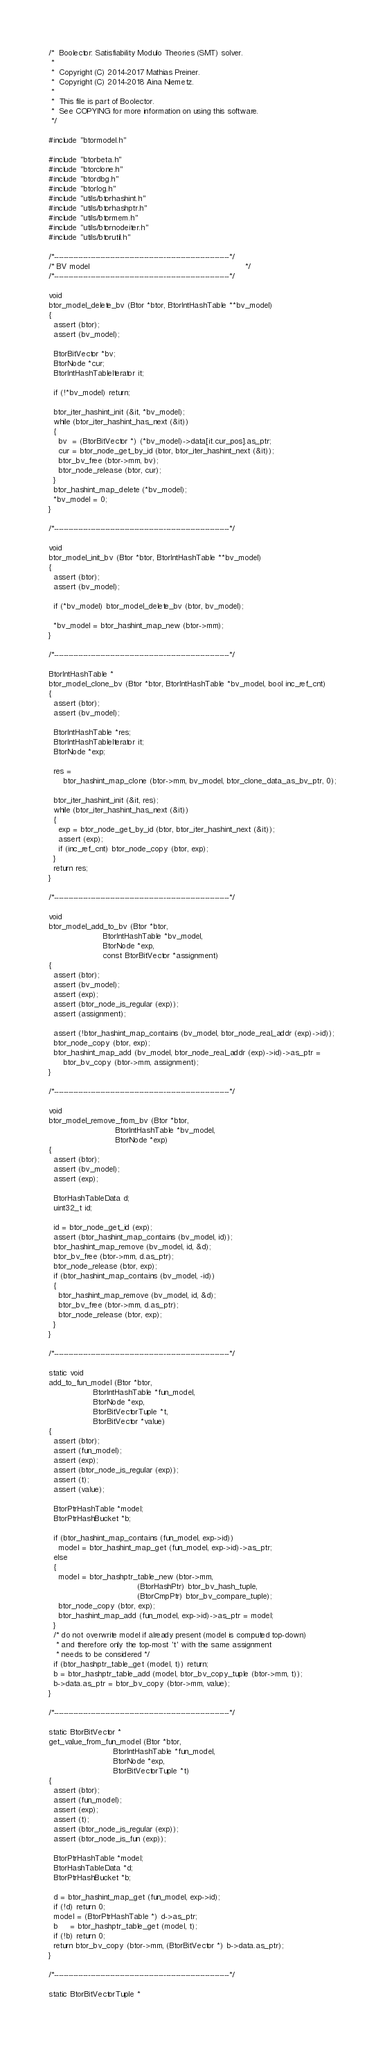Convert code to text. <code><loc_0><loc_0><loc_500><loc_500><_C_>/*  Boolector: Satisfiability Modulo Theories (SMT) solver.
 *
 *  Copyright (C) 2014-2017 Mathias Preiner.
 *  Copyright (C) 2014-2018 Aina Niemetz.
 *
 *  This file is part of Boolector.
 *  See COPYING for more information on using this software.
 */

#include "btormodel.h"

#include "btorbeta.h"
#include "btorclone.h"
#include "btordbg.h"
#include "btorlog.h"
#include "utils/btorhashint.h"
#include "utils/btorhashptr.h"
#include "utils/btormem.h"
#include "utils/btornodeiter.h"
#include "utils/btorutil.h"

/*------------------------------------------------------------------------*/
/* BV model                                                               */
/*------------------------------------------------------------------------*/

void
btor_model_delete_bv (Btor *btor, BtorIntHashTable **bv_model)
{
  assert (btor);
  assert (bv_model);

  BtorBitVector *bv;
  BtorNode *cur;
  BtorIntHashTableIterator it;

  if (!*bv_model) return;

  btor_iter_hashint_init (&it, *bv_model);
  while (btor_iter_hashint_has_next (&it))
  {
    bv  = (BtorBitVector *) (*bv_model)->data[it.cur_pos].as_ptr;
    cur = btor_node_get_by_id (btor, btor_iter_hashint_next (&it));
    btor_bv_free (btor->mm, bv);
    btor_node_release (btor, cur);
  }
  btor_hashint_map_delete (*bv_model);
  *bv_model = 0;
}

/*------------------------------------------------------------------------*/

void
btor_model_init_bv (Btor *btor, BtorIntHashTable **bv_model)
{
  assert (btor);
  assert (bv_model);

  if (*bv_model) btor_model_delete_bv (btor, bv_model);

  *bv_model = btor_hashint_map_new (btor->mm);
}

/*------------------------------------------------------------------------*/

BtorIntHashTable *
btor_model_clone_bv (Btor *btor, BtorIntHashTable *bv_model, bool inc_ref_cnt)
{
  assert (btor);
  assert (bv_model);

  BtorIntHashTable *res;
  BtorIntHashTableIterator it;
  BtorNode *exp;

  res =
      btor_hashint_map_clone (btor->mm, bv_model, btor_clone_data_as_bv_ptr, 0);

  btor_iter_hashint_init (&it, res);
  while (btor_iter_hashint_has_next (&it))
  {
    exp = btor_node_get_by_id (btor, btor_iter_hashint_next (&it));
    assert (exp);
    if (inc_ref_cnt) btor_node_copy (btor, exp);
  }
  return res;
}

/*------------------------------------------------------------------------*/

void
btor_model_add_to_bv (Btor *btor,
                      BtorIntHashTable *bv_model,
                      BtorNode *exp,
                      const BtorBitVector *assignment)
{
  assert (btor);
  assert (bv_model);
  assert (exp);
  assert (btor_node_is_regular (exp));
  assert (assignment);

  assert (!btor_hashint_map_contains (bv_model, btor_node_real_addr (exp)->id));
  btor_node_copy (btor, exp);
  btor_hashint_map_add (bv_model, btor_node_real_addr (exp)->id)->as_ptr =
      btor_bv_copy (btor->mm, assignment);
}

/*------------------------------------------------------------------------*/

void
btor_model_remove_from_bv (Btor *btor,
                           BtorIntHashTable *bv_model,
                           BtorNode *exp)
{
  assert (btor);
  assert (bv_model);
  assert (exp);

  BtorHashTableData d;
  uint32_t id;

  id = btor_node_get_id (exp);
  assert (btor_hashint_map_contains (bv_model, id));
  btor_hashint_map_remove (bv_model, id, &d);
  btor_bv_free (btor->mm, d.as_ptr);
  btor_node_release (btor, exp);
  if (btor_hashint_map_contains (bv_model, -id))
  {
    btor_hashint_map_remove (bv_model, id, &d);
    btor_bv_free (btor->mm, d.as_ptr);
    btor_node_release (btor, exp);
  }
}

/*------------------------------------------------------------------------*/

static void
add_to_fun_model (Btor *btor,
                  BtorIntHashTable *fun_model,
                  BtorNode *exp,
                  BtorBitVectorTuple *t,
                  BtorBitVector *value)
{
  assert (btor);
  assert (fun_model);
  assert (exp);
  assert (btor_node_is_regular (exp));
  assert (t);
  assert (value);

  BtorPtrHashTable *model;
  BtorPtrHashBucket *b;

  if (btor_hashint_map_contains (fun_model, exp->id))
    model = btor_hashint_map_get (fun_model, exp->id)->as_ptr;
  else
  {
    model = btor_hashptr_table_new (btor->mm,
                                    (BtorHashPtr) btor_bv_hash_tuple,
                                    (BtorCmpPtr) btor_bv_compare_tuple);
    btor_node_copy (btor, exp);
    btor_hashint_map_add (fun_model, exp->id)->as_ptr = model;
  }
  /* do not overwrite model if already present (model is computed top-down)
   * and therefore only the top-most 't' with the same assignment
   * needs to be considered */
  if (btor_hashptr_table_get (model, t)) return;
  b = btor_hashptr_table_add (model, btor_bv_copy_tuple (btor->mm, t));
  b->data.as_ptr = btor_bv_copy (btor->mm, value);
}

/*------------------------------------------------------------------------*/

static BtorBitVector *
get_value_from_fun_model (Btor *btor,
                          BtorIntHashTable *fun_model,
                          BtorNode *exp,
                          BtorBitVectorTuple *t)
{
  assert (btor);
  assert (fun_model);
  assert (exp);
  assert (t);
  assert (btor_node_is_regular (exp));
  assert (btor_node_is_fun (exp));

  BtorPtrHashTable *model;
  BtorHashTableData *d;
  BtorPtrHashBucket *b;

  d = btor_hashint_map_get (fun_model, exp->id);
  if (!d) return 0;
  model = (BtorPtrHashTable *) d->as_ptr;
  b     = btor_hashptr_table_get (model, t);
  if (!b) return 0;
  return btor_bv_copy (btor->mm, (BtorBitVector *) b->data.as_ptr);
}

/*------------------------------------------------------------------------*/

static BtorBitVectorTuple *</code> 